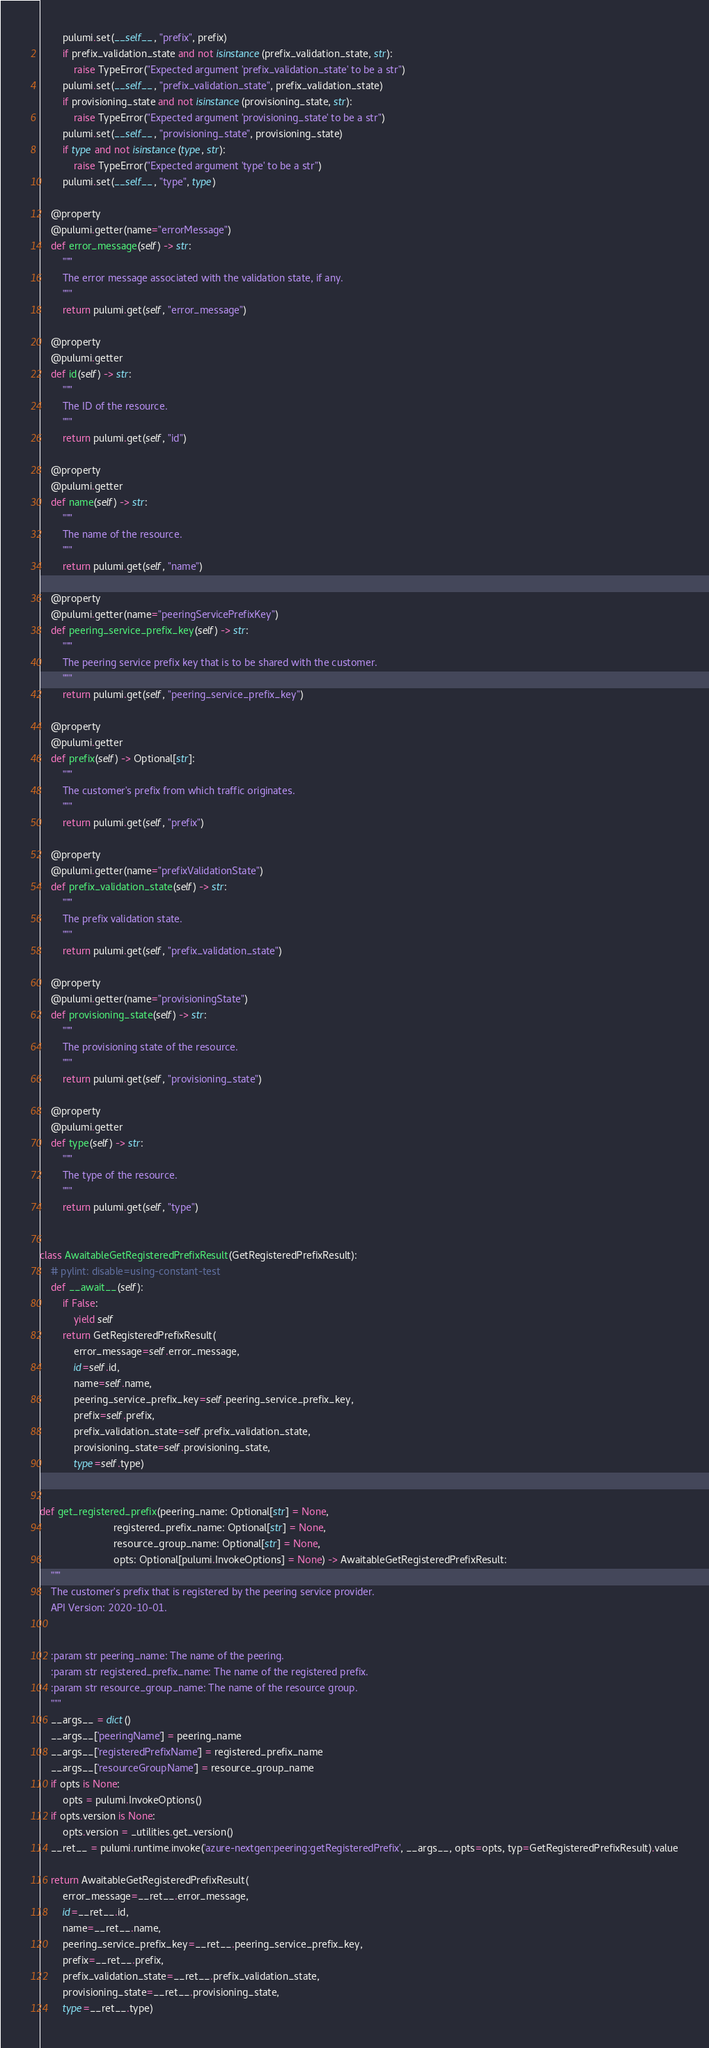Convert code to text. <code><loc_0><loc_0><loc_500><loc_500><_Python_>        pulumi.set(__self__, "prefix", prefix)
        if prefix_validation_state and not isinstance(prefix_validation_state, str):
            raise TypeError("Expected argument 'prefix_validation_state' to be a str")
        pulumi.set(__self__, "prefix_validation_state", prefix_validation_state)
        if provisioning_state and not isinstance(provisioning_state, str):
            raise TypeError("Expected argument 'provisioning_state' to be a str")
        pulumi.set(__self__, "provisioning_state", provisioning_state)
        if type and not isinstance(type, str):
            raise TypeError("Expected argument 'type' to be a str")
        pulumi.set(__self__, "type", type)

    @property
    @pulumi.getter(name="errorMessage")
    def error_message(self) -> str:
        """
        The error message associated with the validation state, if any.
        """
        return pulumi.get(self, "error_message")

    @property
    @pulumi.getter
    def id(self) -> str:
        """
        The ID of the resource.
        """
        return pulumi.get(self, "id")

    @property
    @pulumi.getter
    def name(self) -> str:
        """
        The name of the resource.
        """
        return pulumi.get(self, "name")

    @property
    @pulumi.getter(name="peeringServicePrefixKey")
    def peering_service_prefix_key(self) -> str:
        """
        The peering service prefix key that is to be shared with the customer.
        """
        return pulumi.get(self, "peering_service_prefix_key")

    @property
    @pulumi.getter
    def prefix(self) -> Optional[str]:
        """
        The customer's prefix from which traffic originates.
        """
        return pulumi.get(self, "prefix")

    @property
    @pulumi.getter(name="prefixValidationState")
    def prefix_validation_state(self) -> str:
        """
        The prefix validation state.
        """
        return pulumi.get(self, "prefix_validation_state")

    @property
    @pulumi.getter(name="provisioningState")
    def provisioning_state(self) -> str:
        """
        The provisioning state of the resource.
        """
        return pulumi.get(self, "provisioning_state")

    @property
    @pulumi.getter
    def type(self) -> str:
        """
        The type of the resource.
        """
        return pulumi.get(self, "type")


class AwaitableGetRegisteredPrefixResult(GetRegisteredPrefixResult):
    # pylint: disable=using-constant-test
    def __await__(self):
        if False:
            yield self
        return GetRegisteredPrefixResult(
            error_message=self.error_message,
            id=self.id,
            name=self.name,
            peering_service_prefix_key=self.peering_service_prefix_key,
            prefix=self.prefix,
            prefix_validation_state=self.prefix_validation_state,
            provisioning_state=self.provisioning_state,
            type=self.type)


def get_registered_prefix(peering_name: Optional[str] = None,
                          registered_prefix_name: Optional[str] = None,
                          resource_group_name: Optional[str] = None,
                          opts: Optional[pulumi.InvokeOptions] = None) -> AwaitableGetRegisteredPrefixResult:
    """
    The customer's prefix that is registered by the peering service provider.
    API Version: 2020-10-01.


    :param str peering_name: The name of the peering.
    :param str registered_prefix_name: The name of the registered prefix.
    :param str resource_group_name: The name of the resource group.
    """
    __args__ = dict()
    __args__['peeringName'] = peering_name
    __args__['registeredPrefixName'] = registered_prefix_name
    __args__['resourceGroupName'] = resource_group_name
    if opts is None:
        opts = pulumi.InvokeOptions()
    if opts.version is None:
        opts.version = _utilities.get_version()
    __ret__ = pulumi.runtime.invoke('azure-nextgen:peering:getRegisteredPrefix', __args__, opts=opts, typ=GetRegisteredPrefixResult).value

    return AwaitableGetRegisteredPrefixResult(
        error_message=__ret__.error_message,
        id=__ret__.id,
        name=__ret__.name,
        peering_service_prefix_key=__ret__.peering_service_prefix_key,
        prefix=__ret__.prefix,
        prefix_validation_state=__ret__.prefix_validation_state,
        provisioning_state=__ret__.provisioning_state,
        type=__ret__.type)
</code> 